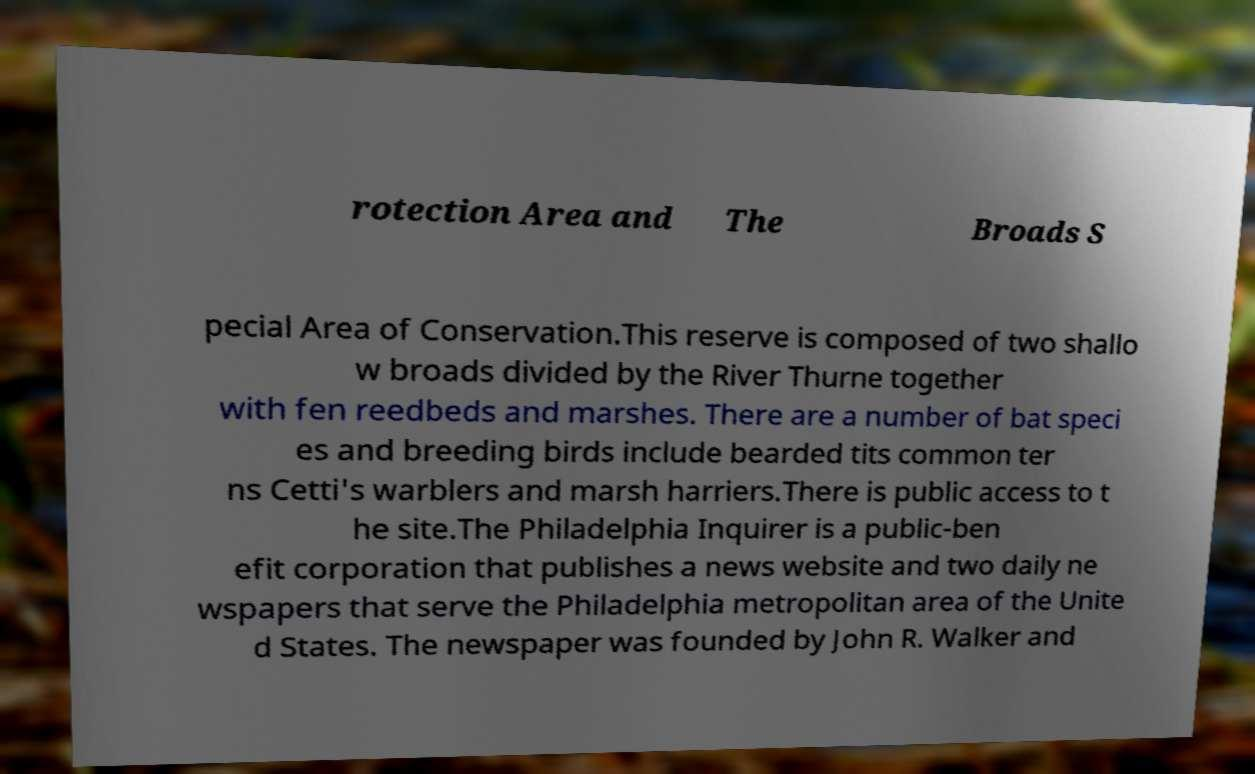Could you assist in decoding the text presented in this image and type it out clearly? rotection Area and The Broads S pecial Area of Conservation.This reserve is composed of two shallo w broads divided by the River Thurne together with fen reedbeds and marshes. There are a number of bat speci es and breeding birds include bearded tits common ter ns Cetti's warblers and marsh harriers.There is public access to t he site.The Philadelphia Inquirer is a public-ben efit corporation that publishes a news website and two daily ne wspapers that serve the Philadelphia metropolitan area of the Unite d States. The newspaper was founded by John R. Walker and 